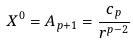Convert formula to latex. <formula><loc_0><loc_0><loc_500><loc_500>X ^ { 0 } = A _ { p + 1 } = \frac { c _ { p } } { r ^ { p - 2 } }</formula> 